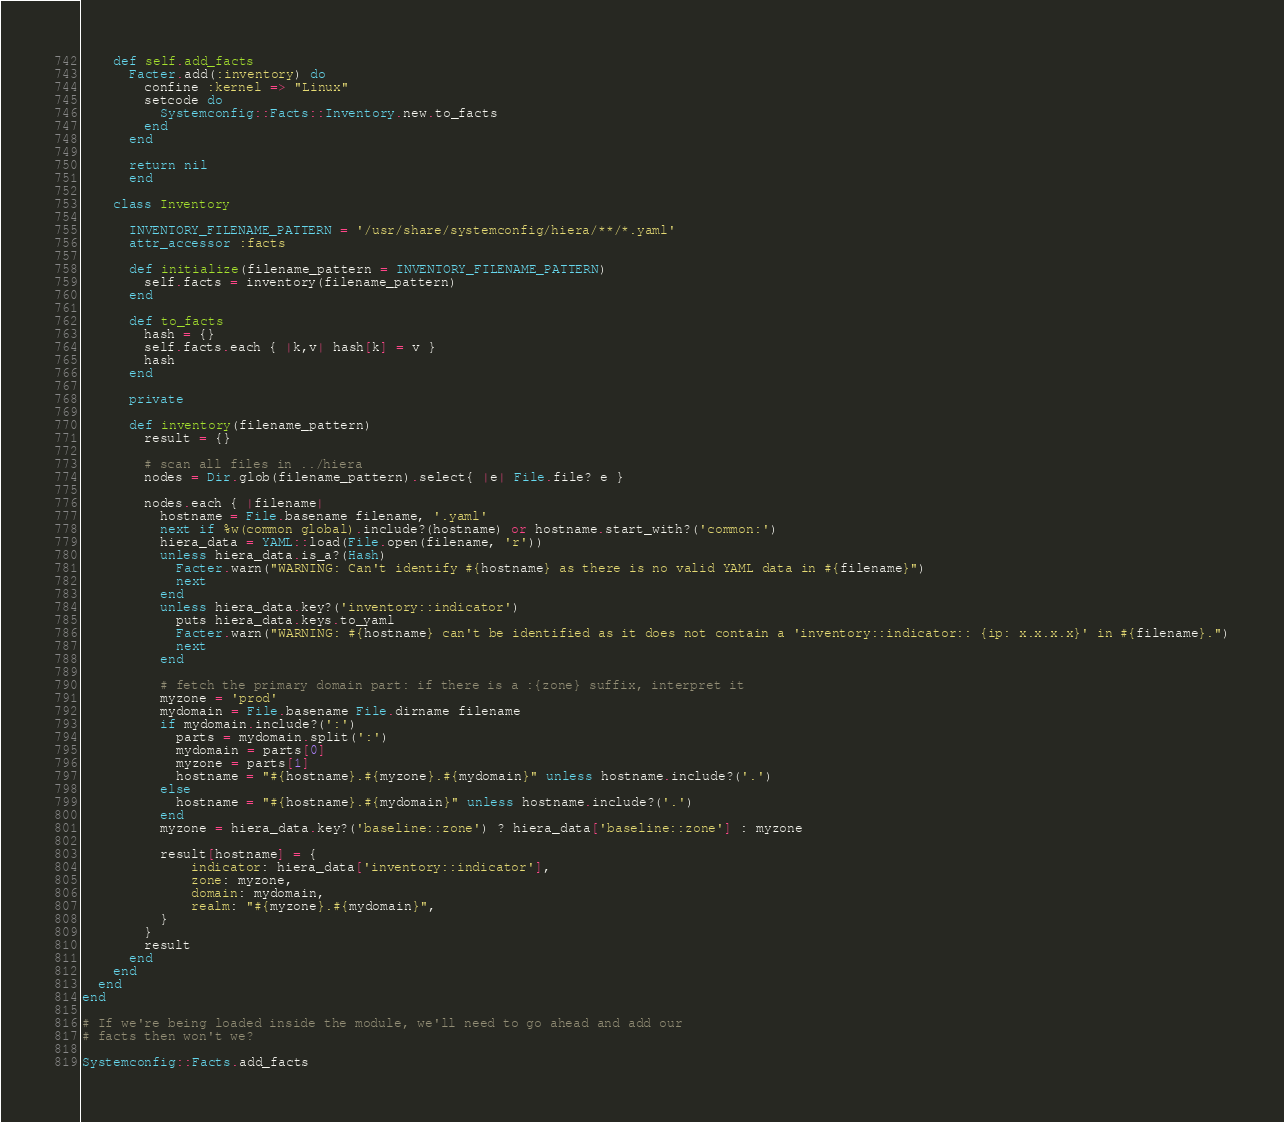<code> <loc_0><loc_0><loc_500><loc_500><_Ruby_>    def self.add_facts
      Facter.add(:inventory) do
        confine :kernel => "Linux"
        setcode do
          Systemconfig::Facts::Inventory.new.to_facts
        end
      end

      return nil
      end

    class Inventory

      INVENTORY_FILENAME_PATTERN = '/usr/share/systemconfig/hiera/**/*.yaml'
      attr_accessor :facts

      def initialize(filename_pattern = INVENTORY_FILENAME_PATTERN)
        self.facts = inventory(filename_pattern)
      end

      def to_facts
        hash = {}
        self.facts.each { |k,v| hash[k] = v }
        hash
      end

      private

      def inventory(filename_pattern)
        result = {}

        # scan all files in ../hiera
        nodes = Dir.glob(filename_pattern).select{ |e| File.file? e }

        nodes.each { |filename|
          hostname = File.basename filename, '.yaml'
          next if %w(common global).include?(hostname) or hostname.start_with?('common:')
          hiera_data = YAML::load(File.open(filename, 'r'))
          unless hiera_data.is_a?(Hash)
            Facter.warn("WARNING: Can't identify #{hostname} as there is no valid YAML data in #{filename}")
            next
          end
          unless hiera_data.key?('inventory::indicator')
            puts hiera_data.keys.to_yaml
            Facter.warn("WARNING: #{hostname} can't be identified as it does not contain a 'inventory::indicator:: {ip: x.x.x.x}' in #{filename}.")
            next
          end

          # fetch the primary domain part: if there is a :{zone} suffix, interpret it
          myzone = 'prod'
          mydomain = File.basename File.dirname filename
          if mydomain.include?(':')
            parts = mydomain.split(':')
            mydomain = parts[0]
            myzone = parts[1]
            hostname = "#{hostname}.#{myzone}.#{mydomain}" unless hostname.include?('.')
          else
            hostname = "#{hostname}.#{mydomain}" unless hostname.include?('.')
          end
          myzone = hiera_data.key?('baseline::zone') ? hiera_data['baseline::zone'] : myzone

          result[hostname] = {
              indicator: hiera_data['inventory::indicator'],
              zone: myzone,
              domain: mydomain,
              realm: "#{myzone}.#{mydomain}",
          }
        }
        result
      end
    end
  end
end

# If we're being loaded inside the module, we'll need to go ahead and add our
# facts then won't we?

Systemconfig::Facts.add_facts
</code> 